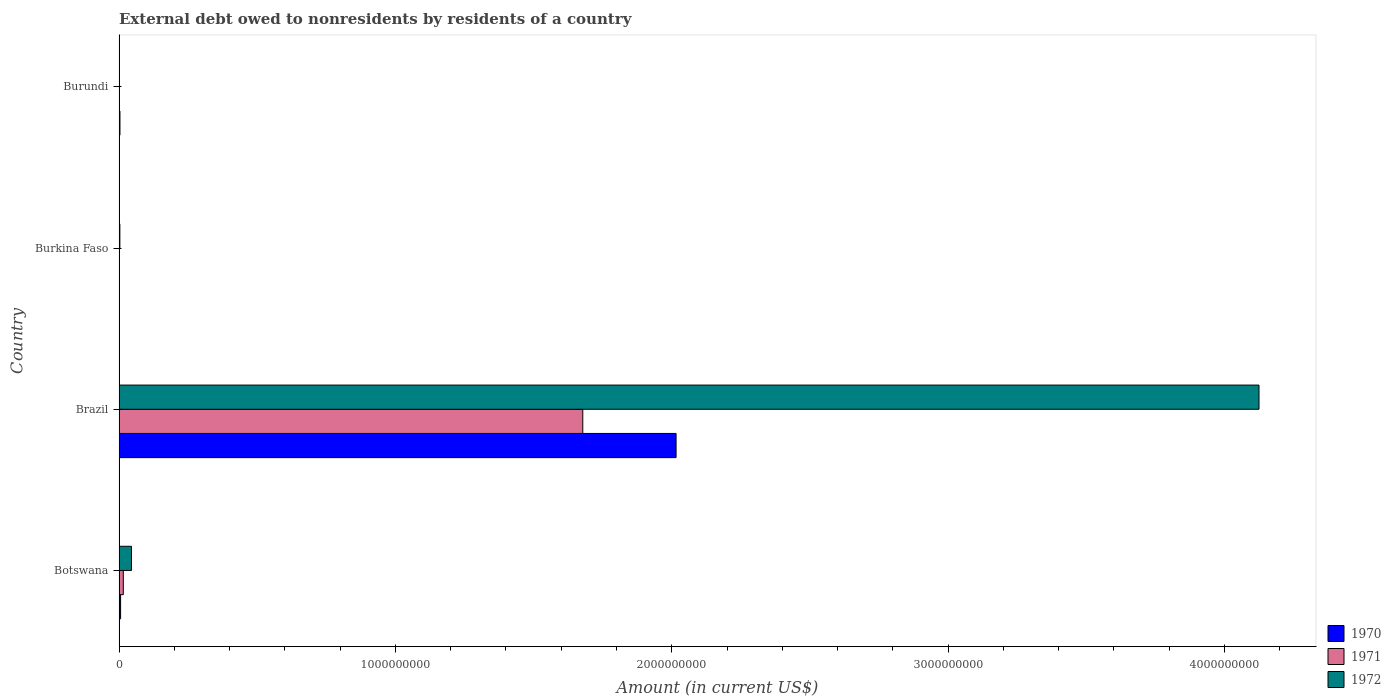How many different coloured bars are there?
Give a very brief answer. 3. Are the number of bars on each tick of the Y-axis equal?
Offer a terse response. No. How many bars are there on the 1st tick from the top?
Offer a terse response. 1. How many bars are there on the 4th tick from the bottom?
Make the answer very short. 1. What is the label of the 2nd group of bars from the top?
Provide a short and direct response. Burkina Faso. In how many cases, is the number of bars for a given country not equal to the number of legend labels?
Provide a short and direct response. 1. What is the external debt owed by residents in 1972 in Brazil?
Offer a very short reply. 4.13e+09. Across all countries, what is the maximum external debt owed by residents in 1972?
Your answer should be very brief. 4.13e+09. In which country was the external debt owed by residents in 1970 maximum?
Provide a short and direct response. Brazil. What is the total external debt owed by residents in 1970 in the graph?
Provide a short and direct response. 2.03e+09. What is the difference between the external debt owed by residents in 1972 in Botswana and that in Burkina Faso?
Ensure brevity in your answer.  4.20e+07. What is the difference between the external debt owed by residents in 1971 in Burkina Faso and the external debt owed by residents in 1972 in Botswana?
Offer a very short reply. -4.36e+07. What is the average external debt owed by residents in 1970 per country?
Your answer should be very brief. 5.06e+08. What is the difference between the external debt owed by residents in 1971 and external debt owed by residents in 1972 in Brazil?
Ensure brevity in your answer.  -2.45e+09. In how many countries, is the external debt owed by residents in 1972 greater than 1000000000 US$?
Offer a very short reply. 1. What is the ratio of the external debt owed by residents in 1970 in Brazil to that in Burundi?
Provide a short and direct response. 620.79. Is the external debt owed by residents in 1972 in Botswana less than that in Burkina Faso?
Provide a short and direct response. No. Is the difference between the external debt owed by residents in 1971 in Botswana and Brazil greater than the difference between the external debt owed by residents in 1972 in Botswana and Brazil?
Provide a short and direct response. Yes. What is the difference between the highest and the second highest external debt owed by residents in 1972?
Offer a very short reply. 4.08e+09. What is the difference between the highest and the lowest external debt owed by residents in 1970?
Give a very brief answer. 2.02e+09. Is it the case that in every country, the sum of the external debt owed by residents in 1970 and external debt owed by residents in 1971 is greater than the external debt owed by residents in 1972?
Provide a short and direct response. No. What is the difference between two consecutive major ticks on the X-axis?
Your response must be concise. 1.00e+09. Are the values on the major ticks of X-axis written in scientific E-notation?
Your response must be concise. No. Does the graph contain any zero values?
Provide a succinct answer. Yes. How many legend labels are there?
Give a very brief answer. 3. How are the legend labels stacked?
Provide a succinct answer. Vertical. What is the title of the graph?
Provide a succinct answer. External debt owed to nonresidents by residents of a country. Does "1970" appear as one of the legend labels in the graph?
Your answer should be very brief. Yes. What is the Amount (in current US$) in 1970 in Botswana?
Your response must be concise. 5.57e+06. What is the Amount (in current US$) of 1971 in Botswana?
Give a very brief answer. 1.54e+07. What is the Amount (in current US$) of 1972 in Botswana?
Make the answer very short. 4.50e+07. What is the Amount (in current US$) in 1970 in Brazil?
Your answer should be compact. 2.02e+09. What is the Amount (in current US$) in 1971 in Brazil?
Keep it short and to the point. 1.68e+09. What is the Amount (in current US$) in 1972 in Brazil?
Provide a succinct answer. 4.13e+09. What is the Amount (in current US$) of 1970 in Burkina Faso?
Keep it short and to the point. 6.51e+05. What is the Amount (in current US$) in 1971 in Burkina Faso?
Your answer should be compact. 1.32e+06. What is the Amount (in current US$) of 1972 in Burkina Faso?
Your response must be concise. 2.91e+06. What is the Amount (in current US$) in 1970 in Burundi?
Your answer should be very brief. 3.25e+06. What is the Amount (in current US$) in 1971 in Burundi?
Offer a very short reply. 0. What is the Amount (in current US$) in 1972 in Burundi?
Ensure brevity in your answer.  0. Across all countries, what is the maximum Amount (in current US$) of 1970?
Provide a short and direct response. 2.02e+09. Across all countries, what is the maximum Amount (in current US$) in 1971?
Ensure brevity in your answer.  1.68e+09. Across all countries, what is the maximum Amount (in current US$) in 1972?
Provide a short and direct response. 4.13e+09. Across all countries, what is the minimum Amount (in current US$) in 1970?
Your answer should be very brief. 6.51e+05. Across all countries, what is the minimum Amount (in current US$) of 1972?
Your answer should be compact. 0. What is the total Amount (in current US$) in 1970 in the graph?
Your answer should be compact. 2.03e+09. What is the total Amount (in current US$) in 1971 in the graph?
Give a very brief answer. 1.69e+09. What is the total Amount (in current US$) of 1972 in the graph?
Ensure brevity in your answer.  4.17e+09. What is the difference between the Amount (in current US$) of 1970 in Botswana and that in Brazil?
Make the answer very short. -2.01e+09. What is the difference between the Amount (in current US$) of 1971 in Botswana and that in Brazil?
Give a very brief answer. -1.66e+09. What is the difference between the Amount (in current US$) of 1972 in Botswana and that in Brazil?
Offer a terse response. -4.08e+09. What is the difference between the Amount (in current US$) in 1970 in Botswana and that in Burkina Faso?
Offer a very short reply. 4.92e+06. What is the difference between the Amount (in current US$) of 1971 in Botswana and that in Burkina Faso?
Give a very brief answer. 1.41e+07. What is the difference between the Amount (in current US$) of 1972 in Botswana and that in Burkina Faso?
Make the answer very short. 4.20e+07. What is the difference between the Amount (in current US$) of 1970 in Botswana and that in Burundi?
Offer a terse response. 2.32e+06. What is the difference between the Amount (in current US$) of 1970 in Brazil and that in Burkina Faso?
Give a very brief answer. 2.02e+09. What is the difference between the Amount (in current US$) in 1971 in Brazil and that in Burkina Faso?
Provide a succinct answer. 1.68e+09. What is the difference between the Amount (in current US$) in 1972 in Brazil and that in Burkina Faso?
Keep it short and to the point. 4.12e+09. What is the difference between the Amount (in current US$) in 1970 in Brazil and that in Burundi?
Provide a short and direct response. 2.01e+09. What is the difference between the Amount (in current US$) of 1970 in Burkina Faso and that in Burundi?
Offer a terse response. -2.60e+06. What is the difference between the Amount (in current US$) of 1970 in Botswana and the Amount (in current US$) of 1971 in Brazil?
Your answer should be compact. -1.67e+09. What is the difference between the Amount (in current US$) in 1970 in Botswana and the Amount (in current US$) in 1972 in Brazil?
Offer a terse response. -4.12e+09. What is the difference between the Amount (in current US$) in 1971 in Botswana and the Amount (in current US$) in 1972 in Brazil?
Give a very brief answer. -4.11e+09. What is the difference between the Amount (in current US$) of 1970 in Botswana and the Amount (in current US$) of 1971 in Burkina Faso?
Make the answer very short. 4.25e+06. What is the difference between the Amount (in current US$) of 1970 in Botswana and the Amount (in current US$) of 1972 in Burkina Faso?
Ensure brevity in your answer.  2.66e+06. What is the difference between the Amount (in current US$) in 1971 in Botswana and the Amount (in current US$) in 1972 in Burkina Faso?
Provide a succinct answer. 1.25e+07. What is the difference between the Amount (in current US$) of 1970 in Brazil and the Amount (in current US$) of 1971 in Burkina Faso?
Make the answer very short. 2.01e+09. What is the difference between the Amount (in current US$) of 1970 in Brazil and the Amount (in current US$) of 1972 in Burkina Faso?
Ensure brevity in your answer.  2.01e+09. What is the difference between the Amount (in current US$) of 1971 in Brazil and the Amount (in current US$) of 1972 in Burkina Faso?
Ensure brevity in your answer.  1.68e+09. What is the average Amount (in current US$) of 1970 per country?
Keep it short and to the point. 5.06e+08. What is the average Amount (in current US$) of 1971 per country?
Your response must be concise. 4.24e+08. What is the average Amount (in current US$) in 1972 per country?
Keep it short and to the point. 1.04e+09. What is the difference between the Amount (in current US$) in 1970 and Amount (in current US$) in 1971 in Botswana?
Offer a very short reply. -9.82e+06. What is the difference between the Amount (in current US$) in 1970 and Amount (in current US$) in 1972 in Botswana?
Ensure brevity in your answer.  -3.94e+07. What is the difference between the Amount (in current US$) of 1971 and Amount (in current US$) of 1972 in Botswana?
Offer a terse response. -2.96e+07. What is the difference between the Amount (in current US$) in 1970 and Amount (in current US$) in 1971 in Brazil?
Keep it short and to the point. 3.38e+08. What is the difference between the Amount (in current US$) of 1970 and Amount (in current US$) of 1972 in Brazil?
Provide a short and direct response. -2.11e+09. What is the difference between the Amount (in current US$) of 1971 and Amount (in current US$) of 1972 in Brazil?
Give a very brief answer. -2.45e+09. What is the difference between the Amount (in current US$) of 1970 and Amount (in current US$) of 1971 in Burkina Faso?
Offer a terse response. -6.68e+05. What is the difference between the Amount (in current US$) in 1970 and Amount (in current US$) in 1972 in Burkina Faso?
Give a very brief answer. -2.26e+06. What is the difference between the Amount (in current US$) in 1971 and Amount (in current US$) in 1972 in Burkina Faso?
Provide a short and direct response. -1.59e+06. What is the ratio of the Amount (in current US$) in 1970 in Botswana to that in Brazil?
Your answer should be compact. 0. What is the ratio of the Amount (in current US$) in 1971 in Botswana to that in Brazil?
Provide a short and direct response. 0.01. What is the ratio of the Amount (in current US$) of 1972 in Botswana to that in Brazil?
Your answer should be compact. 0.01. What is the ratio of the Amount (in current US$) in 1970 in Botswana to that in Burkina Faso?
Your answer should be very brief. 8.55. What is the ratio of the Amount (in current US$) in 1971 in Botswana to that in Burkina Faso?
Give a very brief answer. 11.67. What is the ratio of the Amount (in current US$) of 1972 in Botswana to that in Burkina Faso?
Give a very brief answer. 15.47. What is the ratio of the Amount (in current US$) in 1970 in Botswana to that in Burundi?
Your answer should be compact. 1.71. What is the ratio of the Amount (in current US$) of 1970 in Brazil to that in Burkina Faso?
Provide a short and direct response. 3096.3. What is the ratio of the Amount (in current US$) in 1971 in Brazil to that in Burkina Faso?
Your response must be concise. 1272.21. What is the ratio of the Amount (in current US$) of 1972 in Brazil to that in Burkina Faso?
Your answer should be compact. 1419.49. What is the ratio of the Amount (in current US$) of 1970 in Brazil to that in Burundi?
Keep it short and to the point. 620.79. What is the ratio of the Amount (in current US$) in 1970 in Burkina Faso to that in Burundi?
Give a very brief answer. 0.2. What is the difference between the highest and the second highest Amount (in current US$) in 1970?
Your answer should be very brief. 2.01e+09. What is the difference between the highest and the second highest Amount (in current US$) in 1971?
Your answer should be very brief. 1.66e+09. What is the difference between the highest and the second highest Amount (in current US$) in 1972?
Your response must be concise. 4.08e+09. What is the difference between the highest and the lowest Amount (in current US$) of 1970?
Keep it short and to the point. 2.02e+09. What is the difference between the highest and the lowest Amount (in current US$) of 1971?
Your answer should be compact. 1.68e+09. What is the difference between the highest and the lowest Amount (in current US$) in 1972?
Keep it short and to the point. 4.13e+09. 